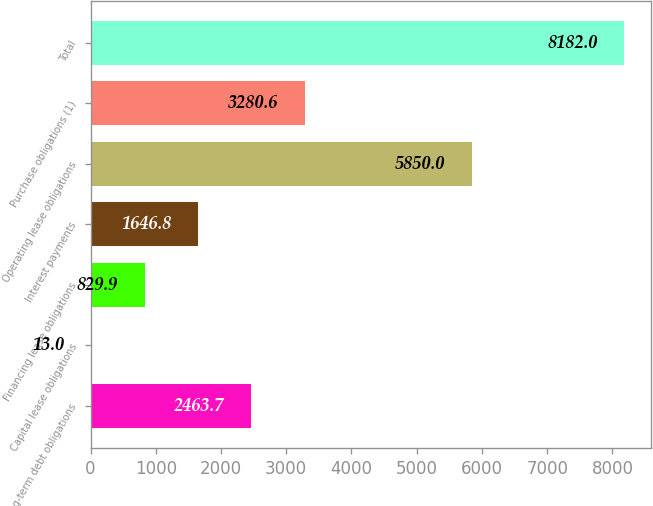Convert chart. <chart><loc_0><loc_0><loc_500><loc_500><bar_chart><fcel>Long-term debt obligations<fcel>Capital lease obligations<fcel>Financing lease obligations<fcel>Interest payments<fcel>Operating lease obligations<fcel>Purchase obligations (1)<fcel>Total<nl><fcel>2463.7<fcel>13<fcel>829.9<fcel>1646.8<fcel>5850<fcel>3280.6<fcel>8182<nl></chart> 